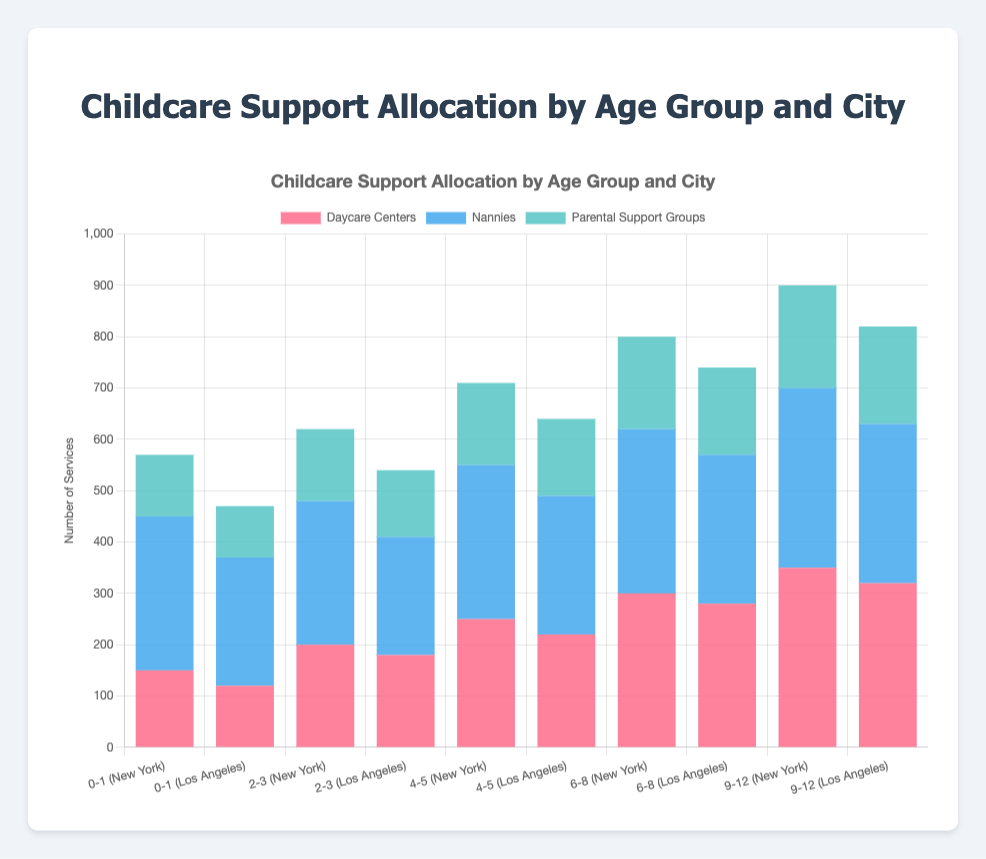What's the total number of daycare centers allocated in New York and Los Angeles for age group 4-5? According to the stacked bar chart for age group 4-5, New York has 250 daycare centers and Los Angeles has 220. Summing these numbers gives 250 + 220 = 470
Answer: 470 Which city has more nannies for age group 2-3? For age group 2-3, New York has 280 nannies and Los Angeles has 230 nannies. Since 280 is greater than 230, New York has more nannies for age group 2-3
Answer: New York Compare the total parental support groups allocated for all age groups between New York and Los Angeles Adding up the parental support groups across all age groups, New York has 120+140+160+180+200=800 and Los Angeles has 100+130+150+170+190=740. New York has more parental support groups in total
Answer: New York Which age group has the highest number of daycare centers in New York? The data shows that the number of daycare centers for each age group in New York is: 0-1: 150, 2-3: 200, 4-5: 250, 6-8: 300, 9-12: 350. Thus, age group 9-12 has the highest number with 350 daycare centers
Answer: 9-12 Between the age groups 0-1 and 6-8, which has more combined support services (daycare centers, nannies, and parental support groups) in Los Angeles? For age group 0-1 in Los Angeles: 120 (daycare) + 250 (nannies) + 100 (parental) = 470. For age group 6-8: 280 (daycare) + 290 (nannies) + 170 (parental) = 740. Age group 6-8 has more combined support services
Answer: 6-8 What's the difference in the number of daycare centers between age group 9-12 and age group 2-3 in Los Angeles? The number of daycare centers for age group 9-12 in Los Angeles is 320 and for age group 2-3 is 180. The difference is 320 - 180 = 140
Answer: 140 Identify the age group with the smallest number of parental support groups in New York The parental support groups in New York for each age group are: 0-1: 120, 2-3: 140, 4-5: 160, 6-8: 180, 9-12: 200. Age group 0-1 has the smallest number with 120
Answer: 0-1 How many more nannies are there for age group 4-5 in New York compared to Los Angeles? The number of nannies for age group 4-5 in New York is 300, and in Los Angeles, it is 270. The difference is 300 - 270 = 30
Answer: 30 